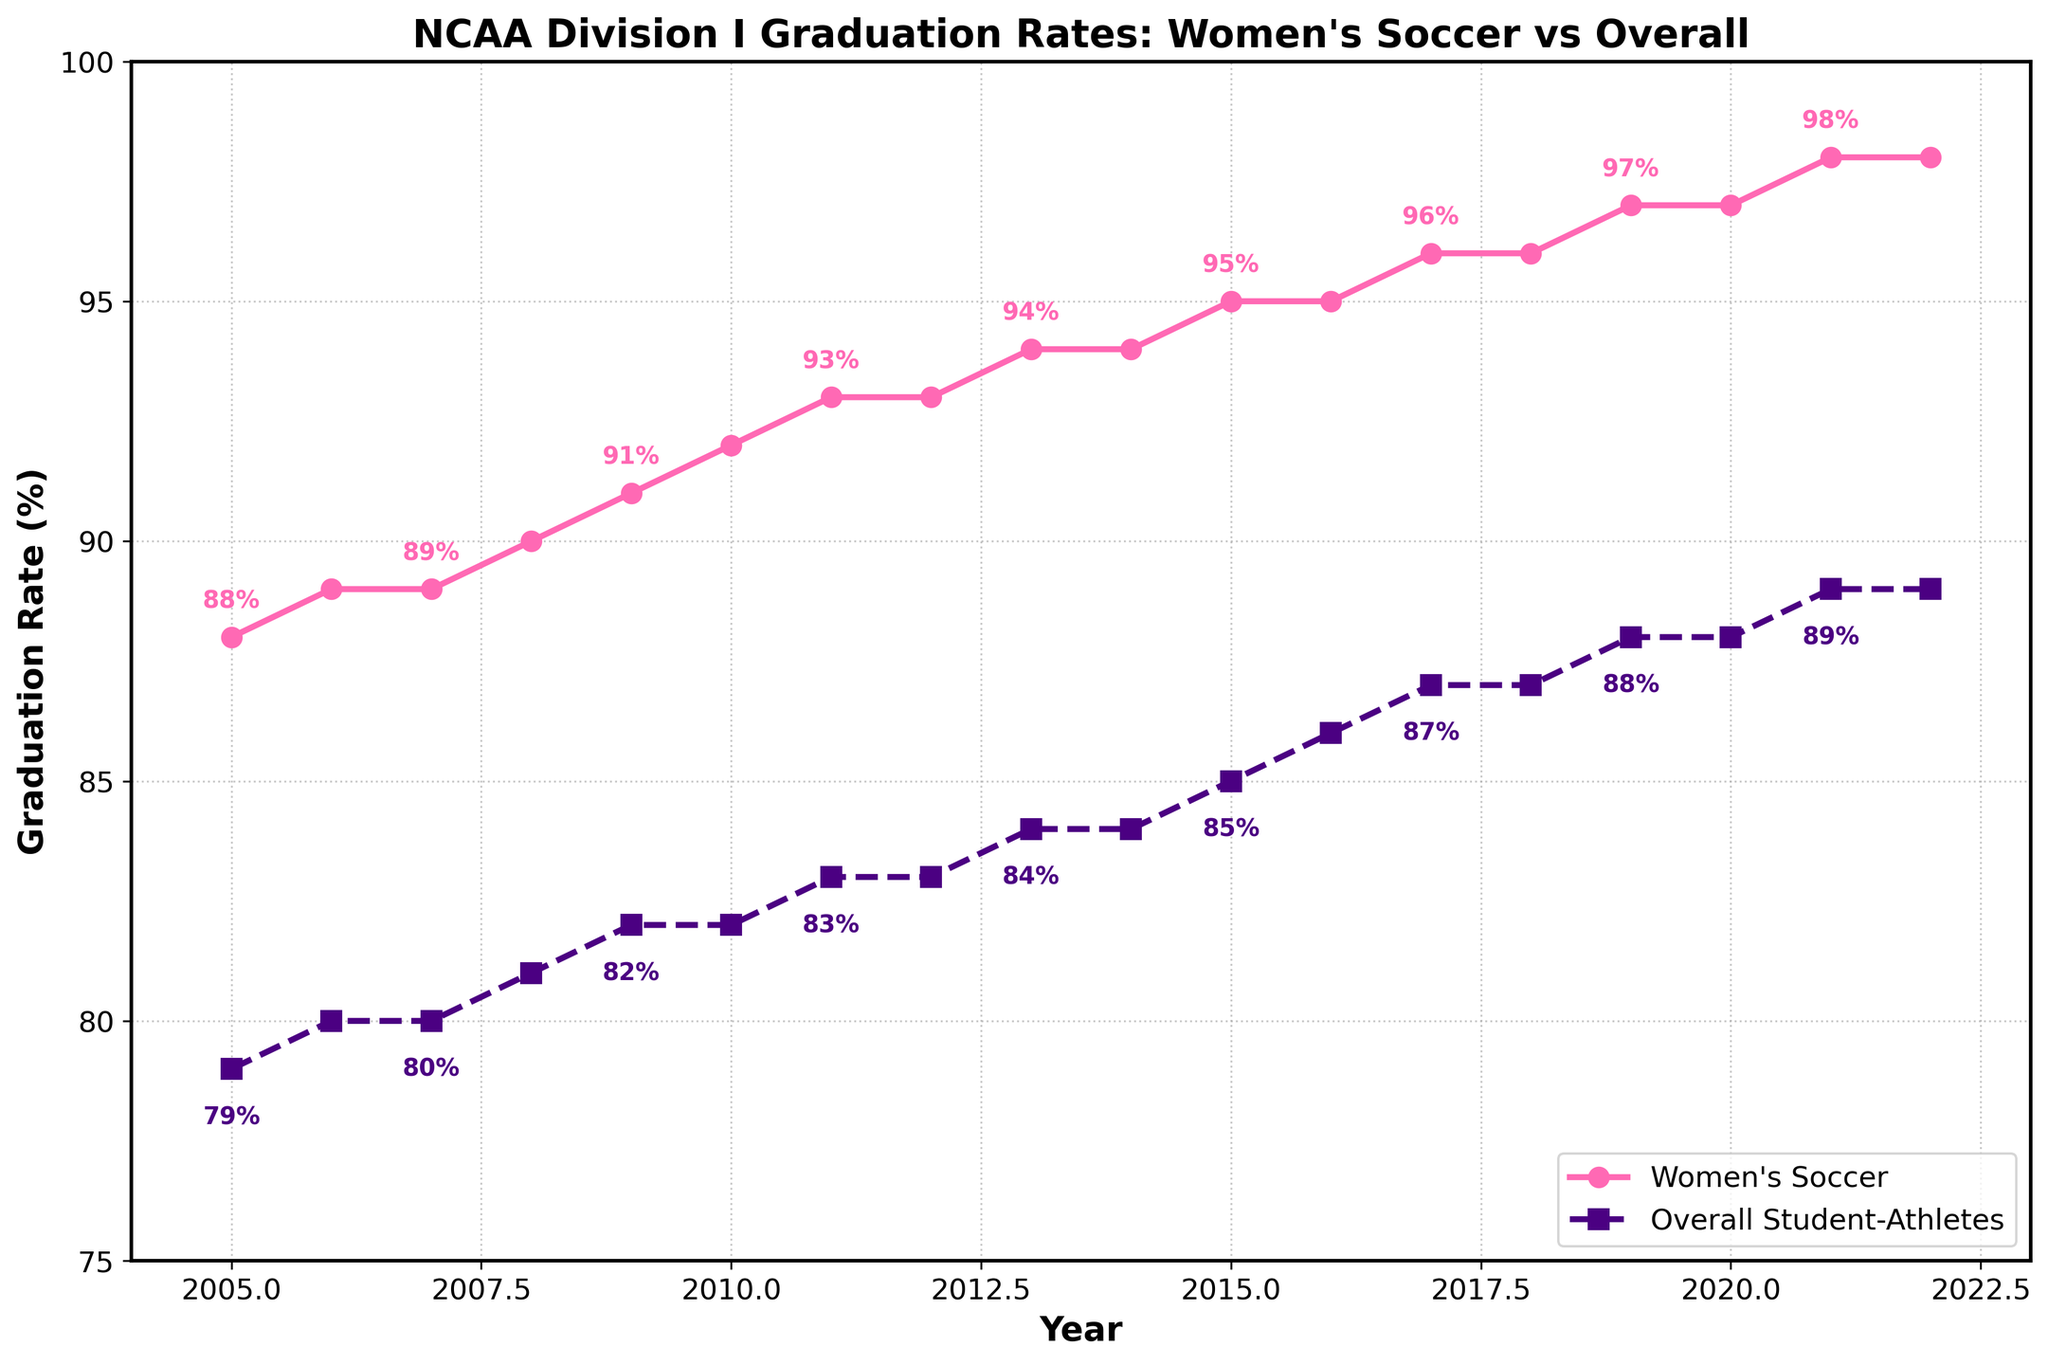What is the graduation rate difference between Women's Soccer players and Overall Student-Athletes in 2005? In 2005, the graduation rate for Women's Soccer players is 88%, and for Overall Student-Athletes, it is 79%. The difference is calculated as 88% - 79% = 9%.
Answer: 9% How many years have Women's Soccer graduation rates been higher than Overall Student-Athlete rates by at least 10%? Examine each year in the data. For each year where the difference between Women's Soccer and Overall Student-Athlete rates is 10% or more, count that year. The years satisfying this criterion are 2015 to 2022, totaling 8 years.
Answer: 8 years Which year showed the highest graduation rate for Women's Soccer players, and what was the rate? By looking at the data, the highest graduation rate for Women's Soccer players occurs in 2021 and 2022, both at 98%.
Answer: 2021 and 2022, 98% What is the overall trend in graduation rates for Women's Soccer players from 2005 to 2022? Analyzing the plot, the graduation rates for Women's Soccer players show a gradual and consistent increase from 88% in 2005 to 98% in 2022, indicating an improving trend.
Answer: Increasing In which years do the Women's Soccer and Overall Student-Athlete graduation rates have the smallest difference? To find the smallest difference, calculate the difference for each year. The smallest difference occurs in 2022 and 2021 with a difference of 9% (98% for Women's Soccer and 89% for Overall Student-Athletes).
Answer: 2022 and 2021 Which group saw a higher increase in graduation rates from 2005 to 2022, Women's Soccer players or Overall Student-Athletes? Calculate the increase for each group by subtracting the rate in 2005 from the rate in 2022. For Women's Soccer: 98% - 88% = 10%. For Overall Student-Athletes: 89% - 79% = 10%. Thus, both groups have the same increase of 10%.
Answer: Both, 10% What is the average graduation rate for Women's Soccer players from 2005 to 2022? Sum the graduation rates for Women's Soccer from 2005 to 2022 and divide by the number of years (18 years): (88 + 89 + 89 + 90 + 91 + 92 + 93 + 93 + 94 + 94 + 95 + 95 + 96 + 96 + 97 + 97 + 98 + 98) / 18 = 93%.
Answer: 93% How did the graduation rates for Overall Student-Athletes change between 2011 and 2016? Calculate the rate difference between 2011 and 2016 for Overall Student-Athletes: 86% in 2016 - 83% in 2011 = 3%. The graduation rate increased by 3% during this period.
Answer: Increased by 3% What is the mid-point graduation rate for Women's Soccer between the highest and lowest recorded rates from 2005 to 2022? The highest graduation rate is 98%, and the lowest is 88%. The mid-point graduation rate is (98 + 88) / 2 = 93%.
Answer: 93% 